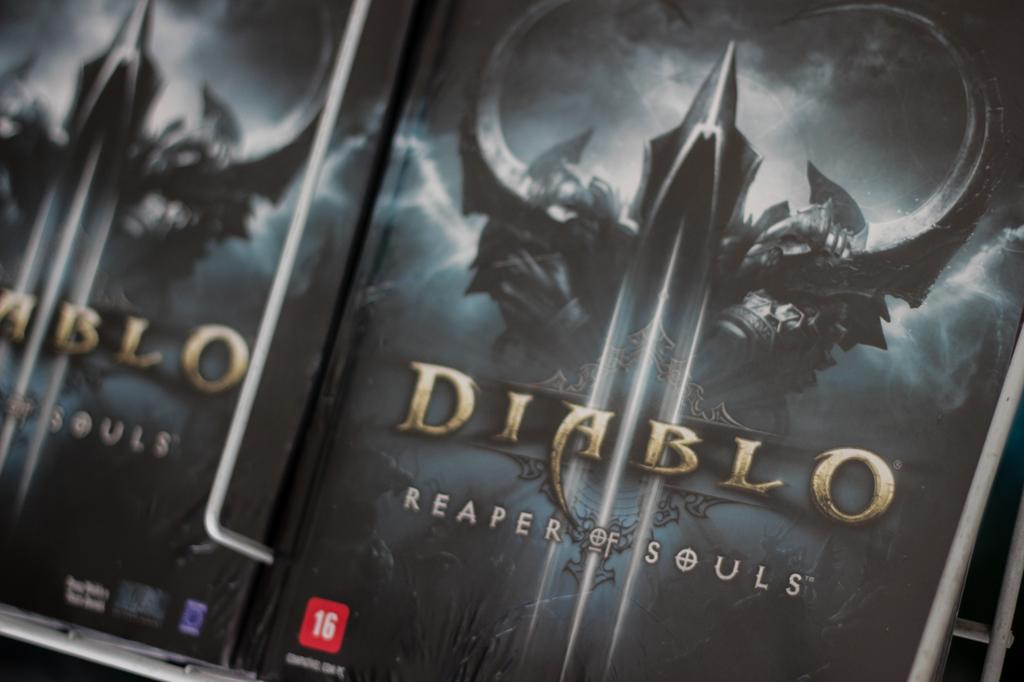Provide a one-sentence caption for the provided image. A Diablo  3 case with a game in it. 